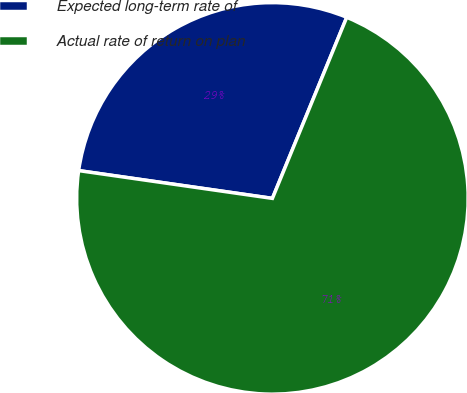Convert chart. <chart><loc_0><loc_0><loc_500><loc_500><pie_chart><fcel>Expected long-term rate of<fcel>Actual rate of return on plan<nl><fcel>28.93%<fcel>71.07%<nl></chart> 